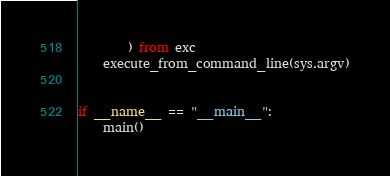<code> <loc_0><loc_0><loc_500><loc_500><_Python_>        ) from exc
    execute_from_command_line(sys.argv)


if __name__ == "__main__":
    main()
</code> 